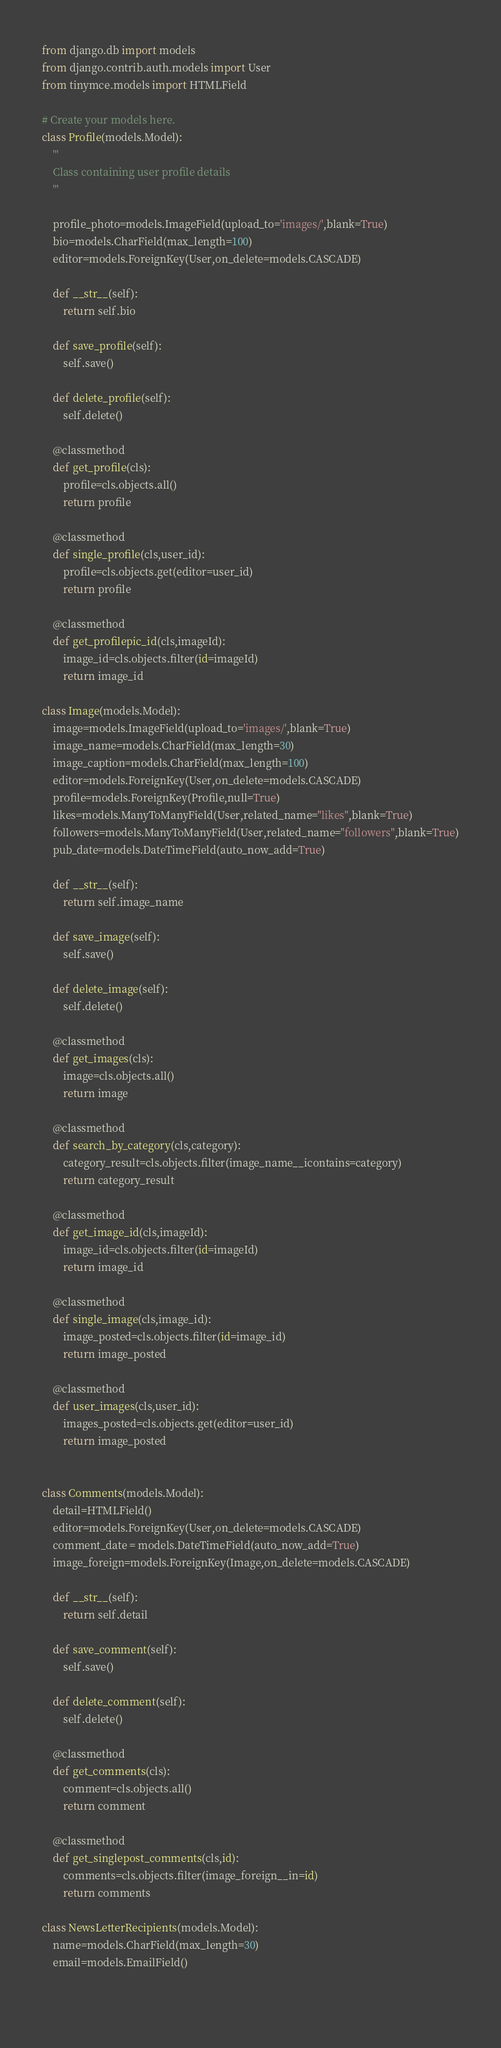Convert code to text. <code><loc_0><loc_0><loc_500><loc_500><_Python_>from django.db import models
from django.contrib.auth.models import User
from tinymce.models import HTMLField

# Create your models here.
class Profile(models.Model):
    '''
    Class containing user profile details
    '''
    
    profile_photo=models.ImageField(upload_to='images/',blank=True)
    bio=models.CharField(max_length=100)
    editor=models.ForeignKey(User,on_delete=models.CASCADE)
    
    def __str__(self):
        return self.bio
    
    def save_profile(self):
        self.save()
        
    def delete_profile(self):
        self.delete()
        
    @classmethod
    def get_profile(cls):
        profile=cls.objects.all()
        return profile
    
    @classmethod
    def single_profile(cls,user_id):
        profile=cls.objects.get(editor=user_id)
        return profile
    
    @classmethod
    def get_profilepic_id(cls,imageId):
        image_id=cls.objects.filter(id=imageId)
        return image_id

class Image(models.Model):
    image=models.ImageField(upload_to='images/',blank=True)
    image_name=models.CharField(max_length=30)
    image_caption=models.CharField(max_length=100)
    editor=models.ForeignKey(User,on_delete=models.CASCADE)
    profile=models.ForeignKey(Profile,null=True)
    likes=models.ManyToManyField(User,related_name="likes",blank=True)
    followers=models.ManyToManyField(User,related_name="followers",blank=True)
    pub_date=models.DateTimeField(auto_now_add=True)
    
    def __str__(self):
        return self.image_name
    
    def save_image(self):
        self.save()
    
    def delete_image(self):
        self.delete()
    
    @classmethod
    def get_images(cls):
        image=cls.objects.all()
        return image
    
    @classmethod
    def search_by_category(cls,category):
        category_result=cls.objects.filter(image_name__icontains=category)
        return category_result
    
    @classmethod
    def get_image_id(cls,imageId):
        image_id=cls.objects.filter(id=imageId)
        return image_id
    
    @classmethod
    def single_image(cls,image_id):
        image_posted=cls.objects.filter(id=image_id)
        return image_posted
    
    @classmethod
    def user_images(cls,user_id):
        images_posted=cls.objects.get(editor=user_id)
        return image_posted
        
        
class Comments(models.Model):
    detail=HTMLField()
    editor=models.ForeignKey(User,on_delete=models.CASCADE)
    comment_date = models.DateTimeField(auto_now_add=True)
    image_foreign=models.ForeignKey(Image,on_delete=models.CASCADE)
    
    def __str__(self):
        return self.detail
    
    def save_comment(self):
        self.save()
        
    def delete_comment(self):
        self.delete()
        
    @classmethod
    def get_comments(cls):
        comment=cls.objects.all()
        return comment
    
    @classmethod
    def get_singlepost_comments(cls,id):
        comments=cls.objects.filter(image_foreign__in=id)
        return comments
    
class NewsLetterRecipients(models.Model):
    name=models.CharField(max_length=30)
    email=models.EmailField()
        
    </code> 